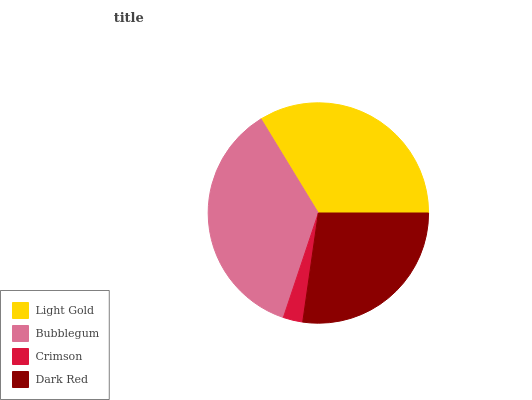Is Crimson the minimum?
Answer yes or no. Yes. Is Bubblegum the maximum?
Answer yes or no. Yes. Is Bubblegum the minimum?
Answer yes or no. No. Is Crimson the maximum?
Answer yes or no. No. Is Bubblegum greater than Crimson?
Answer yes or no. Yes. Is Crimson less than Bubblegum?
Answer yes or no. Yes. Is Crimson greater than Bubblegum?
Answer yes or no. No. Is Bubblegum less than Crimson?
Answer yes or no. No. Is Light Gold the high median?
Answer yes or no. Yes. Is Dark Red the low median?
Answer yes or no. Yes. Is Crimson the high median?
Answer yes or no. No. Is Crimson the low median?
Answer yes or no. No. 